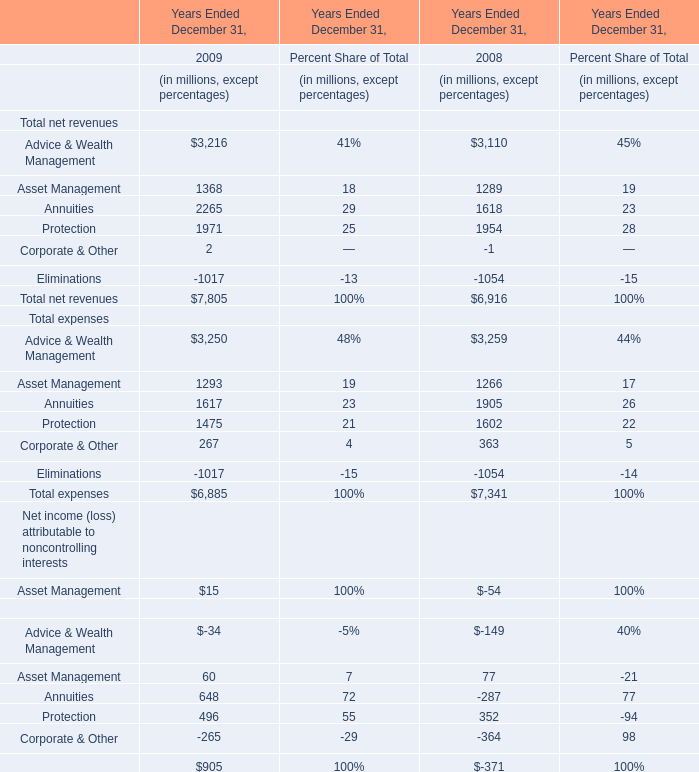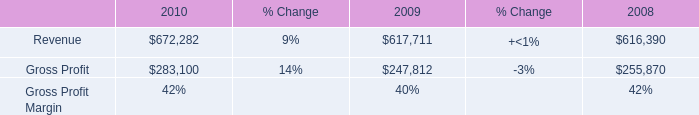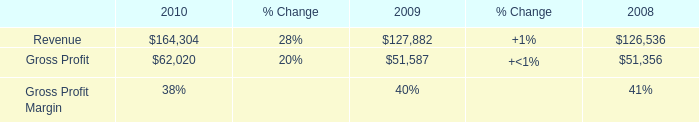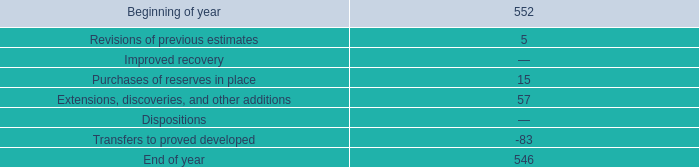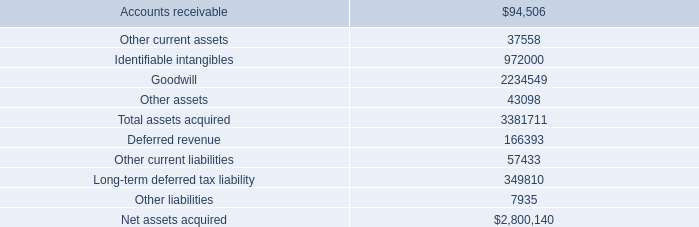What's the average of Asset Management in 2009 and 2008? (in million) 
Computations: ((1368 + 1289) / 2)
Answer: 1328.5. 